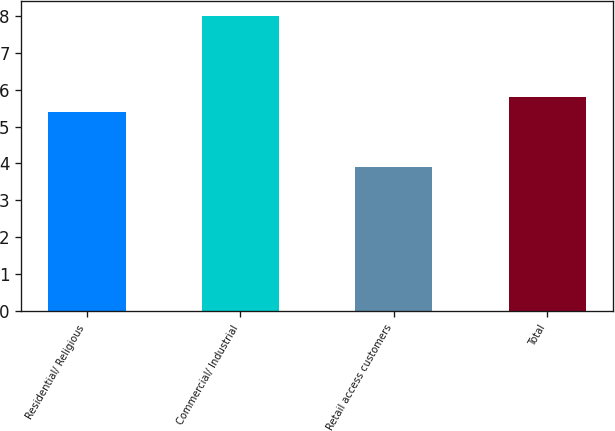Convert chart. <chart><loc_0><loc_0><loc_500><loc_500><bar_chart><fcel>Residential/ Religious<fcel>Commercial/ Industrial<fcel>Retail access customers<fcel>Total<nl><fcel>5.4<fcel>8<fcel>3.9<fcel>5.81<nl></chart> 